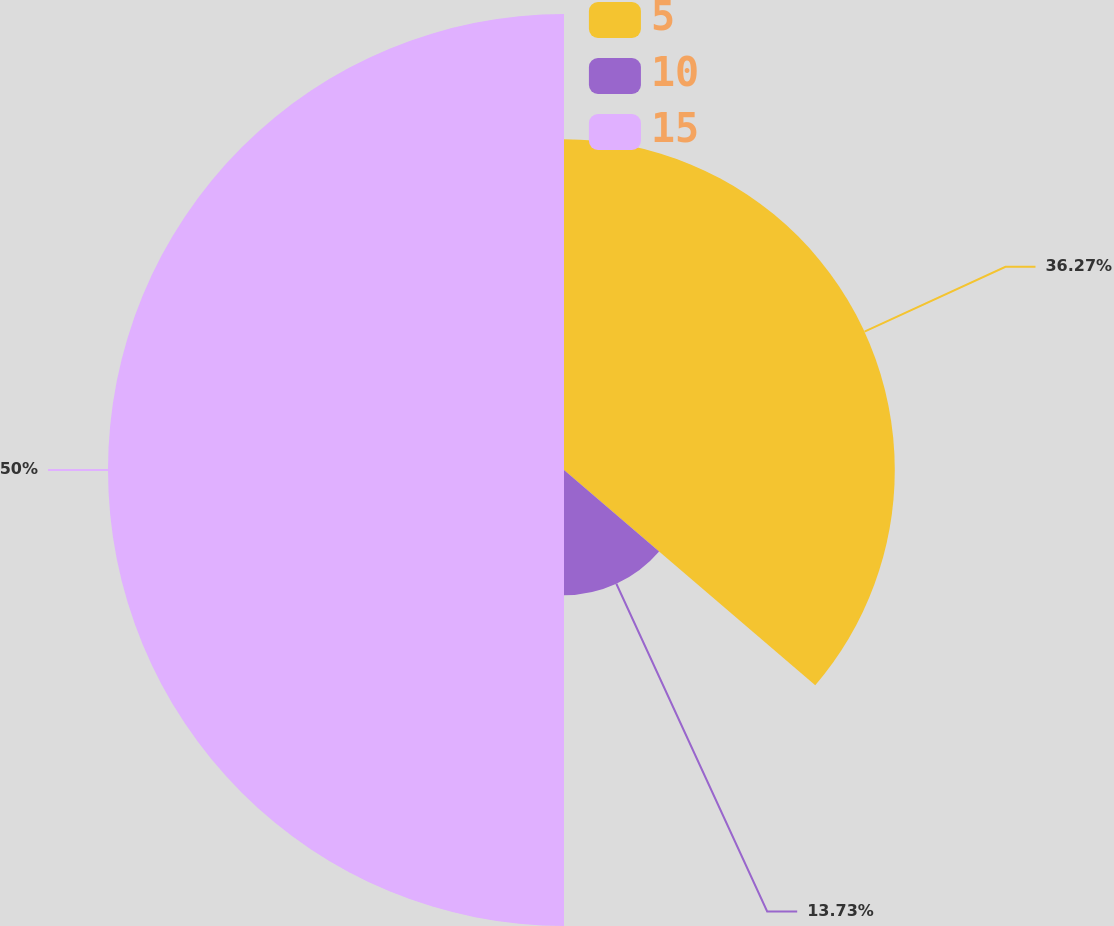<chart> <loc_0><loc_0><loc_500><loc_500><pie_chart><fcel>5<fcel>10<fcel>15<nl><fcel>36.27%<fcel>13.73%<fcel>50.0%<nl></chart> 